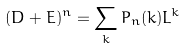Convert formula to latex. <formula><loc_0><loc_0><loc_500><loc_500>( D + E ) ^ { n } = \sum _ { k } P _ { n } ( k ) L ^ { k }</formula> 